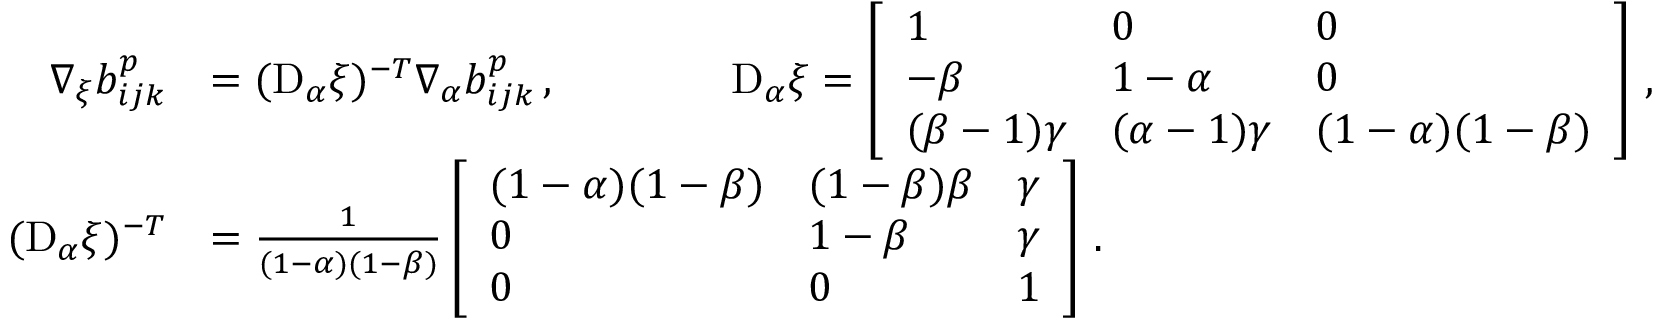Convert formula to latex. <formula><loc_0><loc_0><loc_500><loc_500>\begin{array} { r l } { \nabla _ { \xi } b _ { i j k } ^ { p } } & { = ( D _ { \alpha } \xi ) ^ { - T } \nabla _ { \alpha } b _ { i j k } ^ { p } \, , \quad D _ { \alpha } \xi = \left [ \begin{array} { l l l } { 1 } & { 0 } & { 0 } \\ { - \beta } & { 1 - \alpha } & { 0 } \\ { ( \beta - 1 ) \gamma } & { ( \alpha - 1 ) \gamma } & { ( 1 - \alpha ) ( 1 - \beta ) } \end{array} \right ] \, , } \\ { ( D _ { \alpha } \xi ) ^ { - T } } & { = \frac { 1 } { ( 1 - \alpha ) ( 1 - \beta ) } \left [ \begin{array} { l l l } { ( 1 - \alpha ) ( 1 - \beta ) } & { ( 1 - \beta ) \beta } & { \gamma } \\ { 0 } & { 1 - \beta } & { \gamma } \\ { 0 } & { 0 } & { 1 } \end{array} \right ] \, . } \end{array}</formula> 